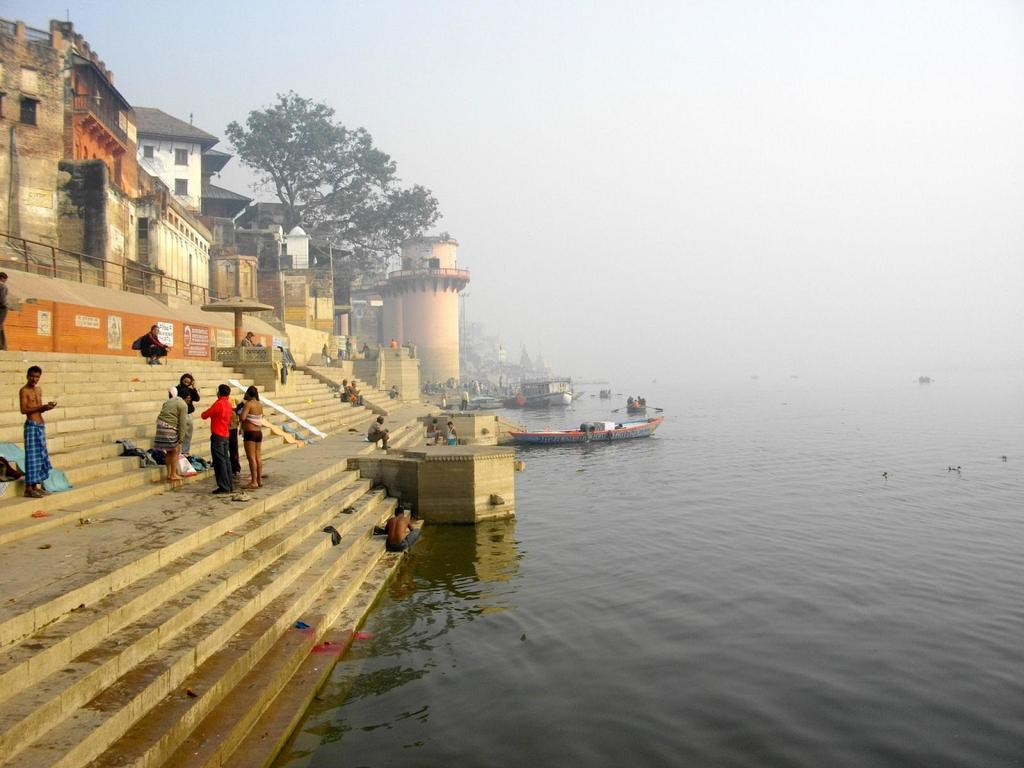What type of natural feature is on the right side of the image? There is a river on the right side of the image. What are the people doing on the left side of the image? There are people standing on steps on the left side of the image. What can be seen in the background of the image? There is a building and a tree in the background of the image. What is visible above the tree in the image? The sky is visible above the tree. Can you tell me how many times the people are adjusting their hats in the image? There is no information about people adjusting their hats in the image. Is there a bridge visible in the image? No, there is no bridge mentioned in the provided facts. 